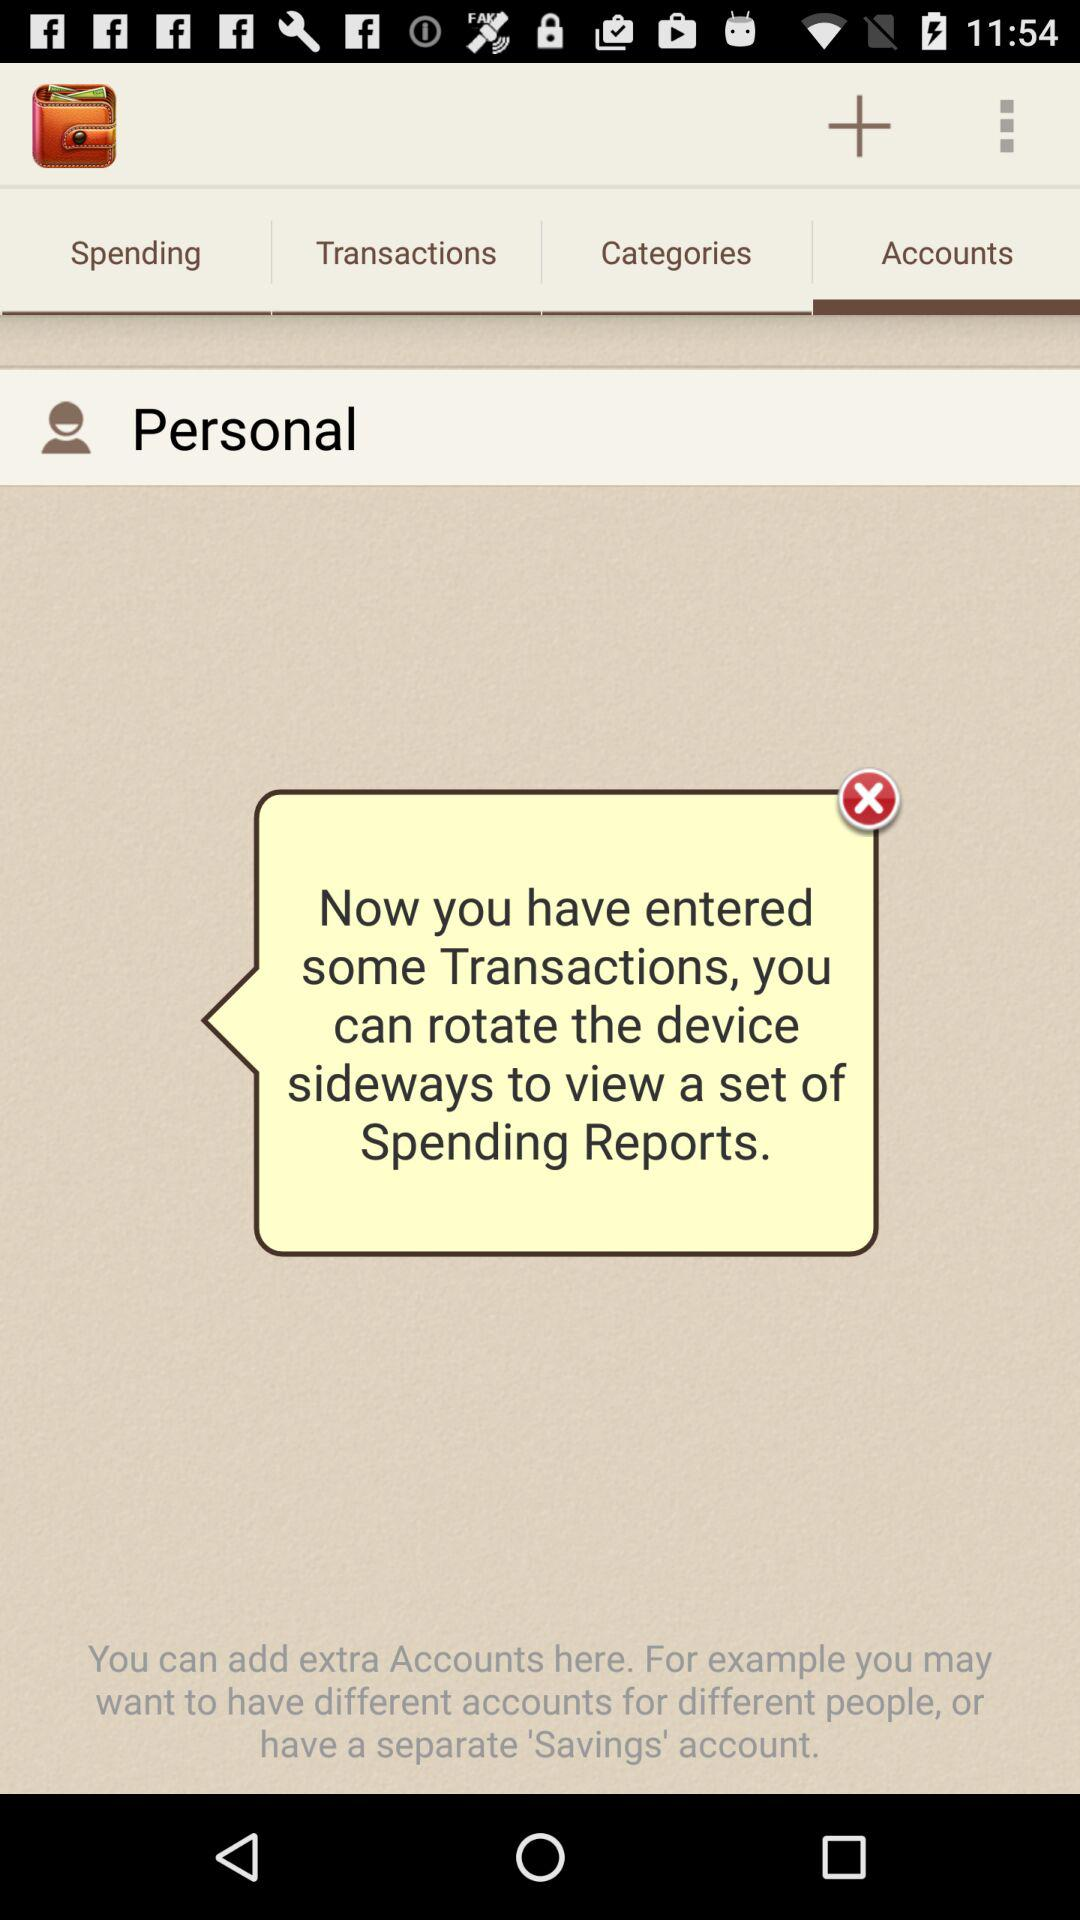Which tab is selected? The selected tab is "Accounts". 